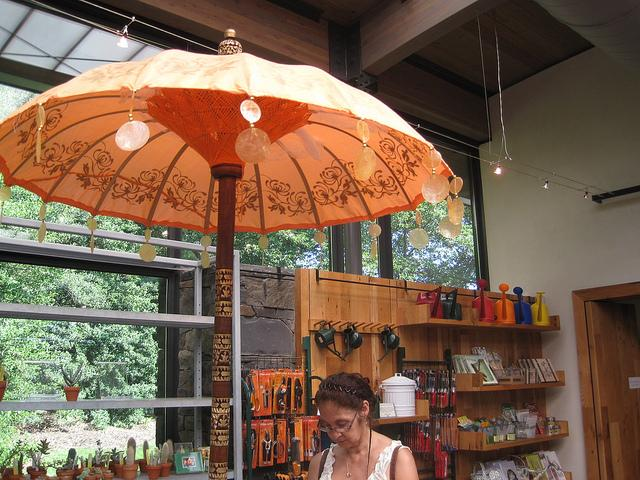What type of shop is this?

Choices:
A) body
B) gift
C) hair
D) auto gift 